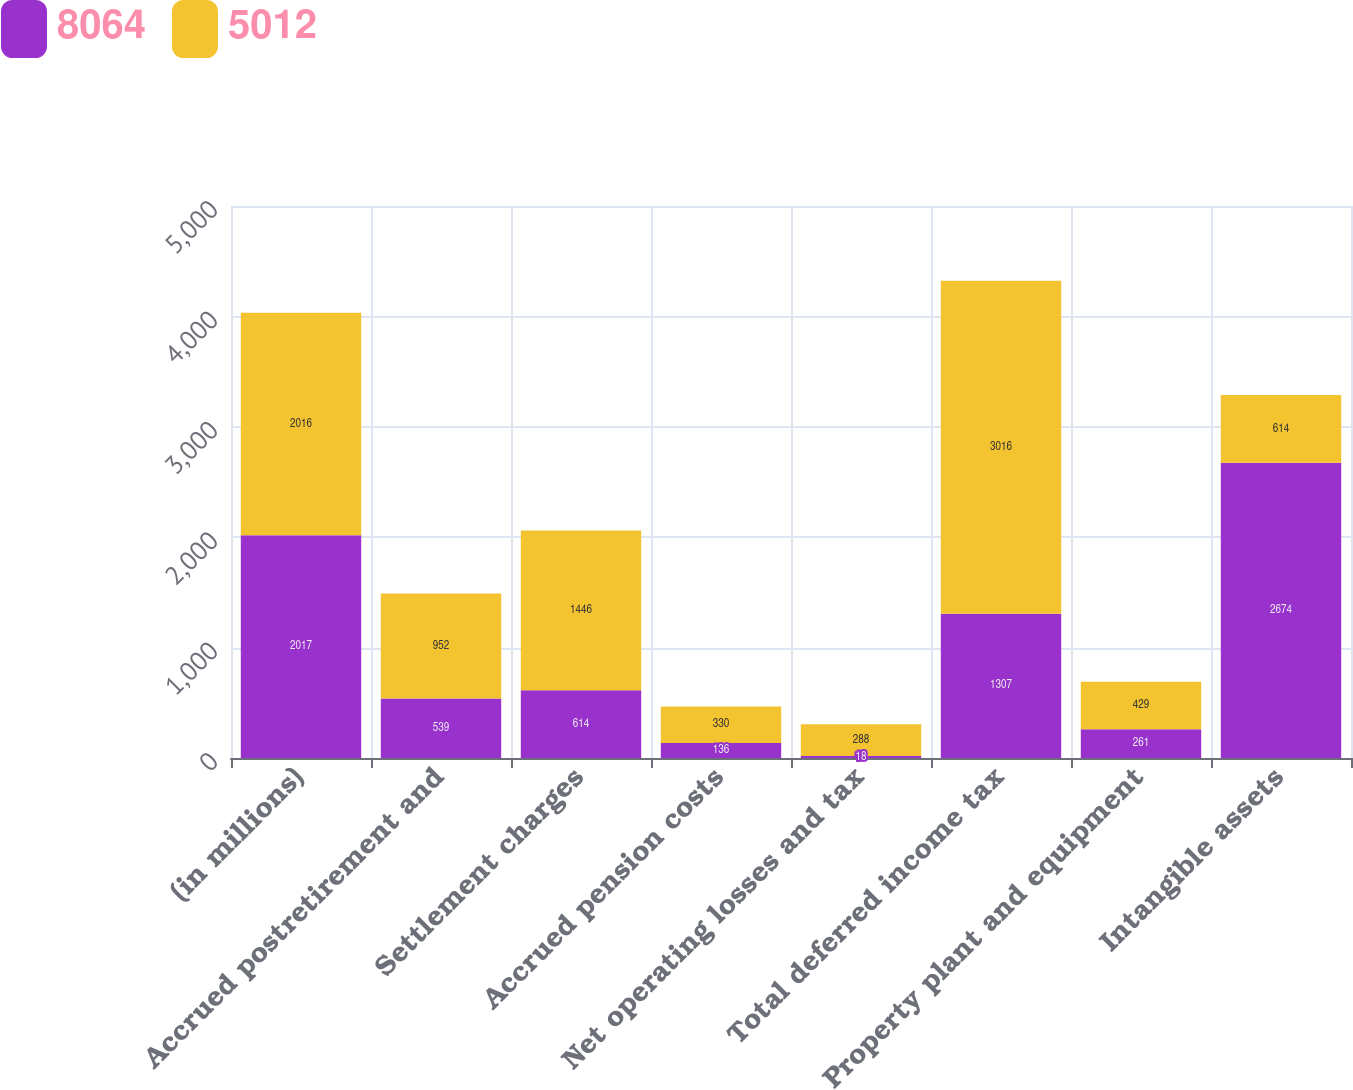<chart> <loc_0><loc_0><loc_500><loc_500><stacked_bar_chart><ecel><fcel>(in millions)<fcel>Accrued postretirement and<fcel>Settlement charges<fcel>Accrued pension costs<fcel>Net operating losses and tax<fcel>Total deferred income tax<fcel>Property plant and equipment<fcel>Intangible assets<nl><fcel>8064<fcel>2017<fcel>539<fcel>614<fcel>136<fcel>18<fcel>1307<fcel>261<fcel>2674<nl><fcel>5012<fcel>2016<fcel>952<fcel>1446<fcel>330<fcel>288<fcel>3016<fcel>429<fcel>614<nl></chart> 